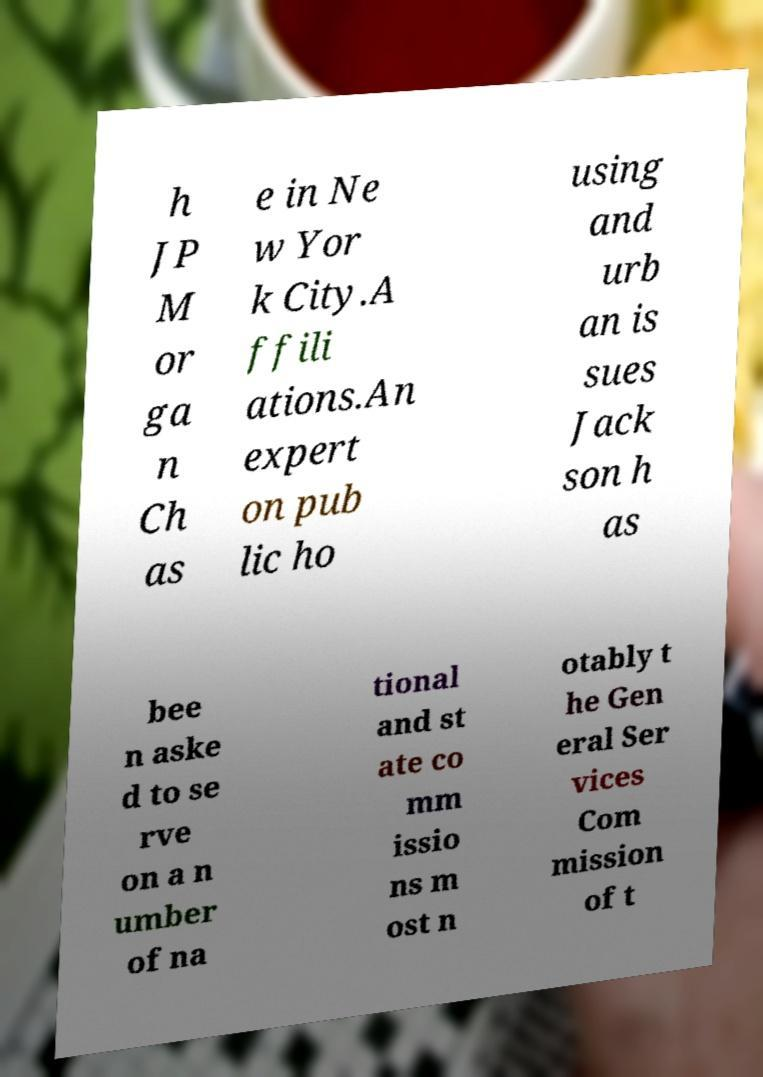For documentation purposes, I need the text within this image transcribed. Could you provide that? h JP M or ga n Ch as e in Ne w Yor k City.A ffili ations.An expert on pub lic ho using and urb an is sues Jack son h as bee n aske d to se rve on a n umber of na tional and st ate co mm issio ns m ost n otably t he Gen eral Ser vices Com mission of t 